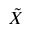<formula> <loc_0><loc_0><loc_500><loc_500>\tilde { X }</formula> 